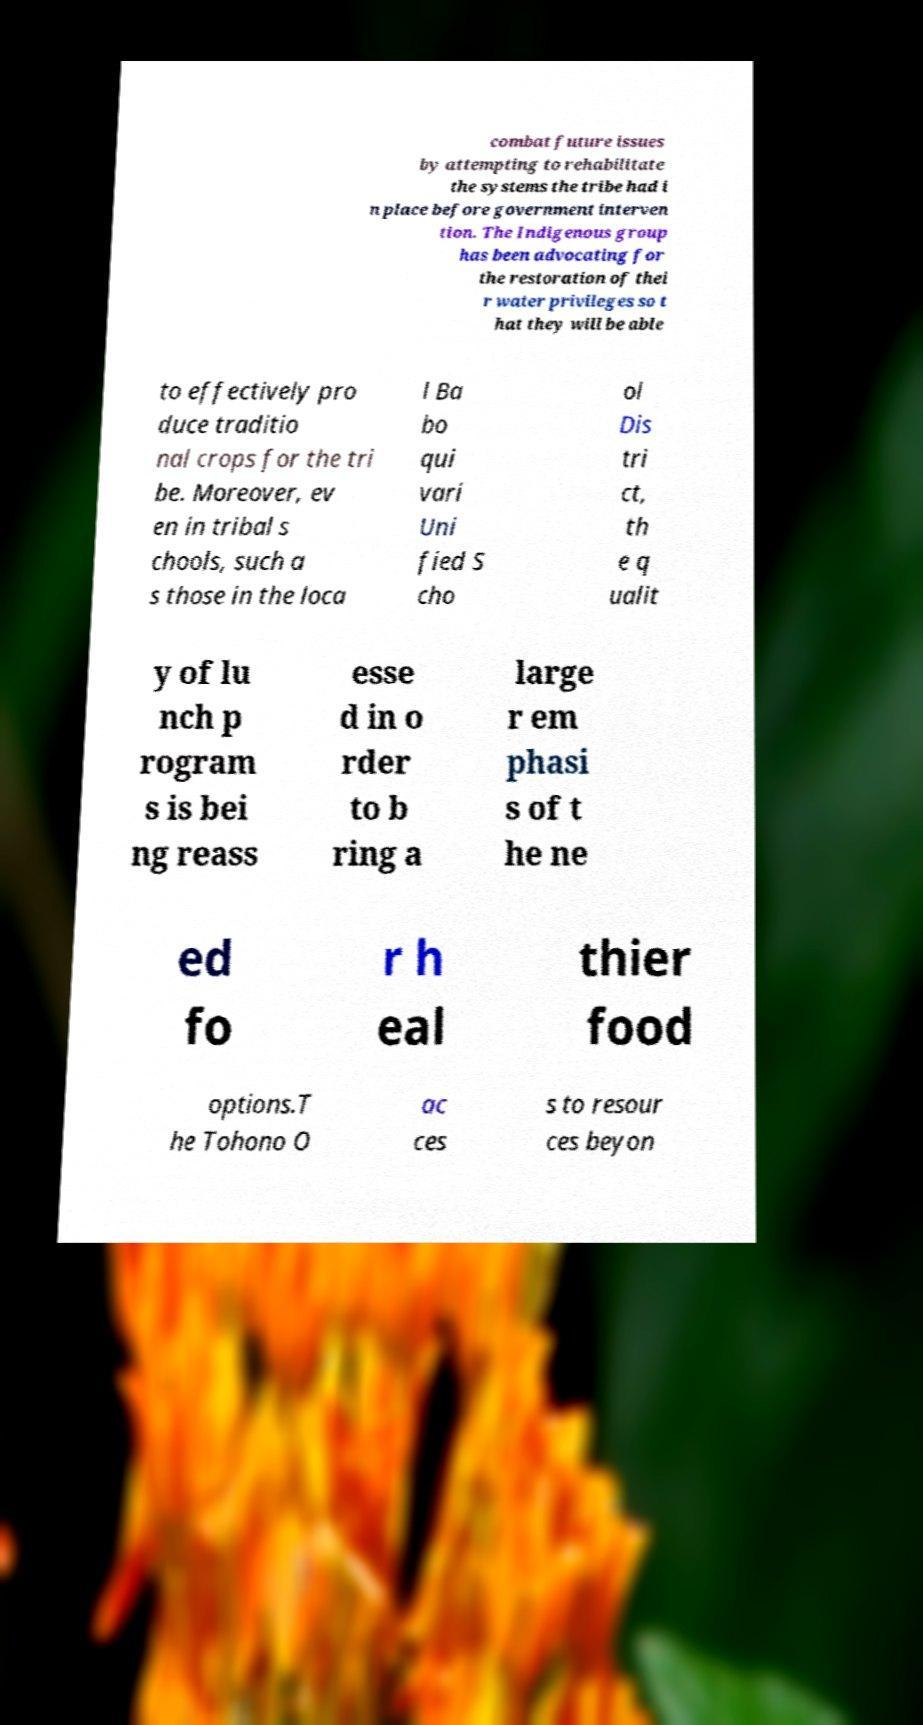I need the written content from this picture converted into text. Can you do that? combat future issues by attempting to rehabilitate the systems the tribe had i n place before government interven tion. The Indigenous group has been advocating for the restoration of thei r water privileges so t hat they will be able to effectively pro duce traditio nal crops for the tri be. Moreover, ev en in tribal s chools, such a s those in the loca l Ba bo qui vari Uni fied S cho ol Dis tri ct, th e q ualit y of lu nch p rogram s is bei ng reass esse d in o rder to b ring a large r em phasi s of t he ne ed fo r h eal thier food options.T he Tohono O ac ces s to resour ces beyon 